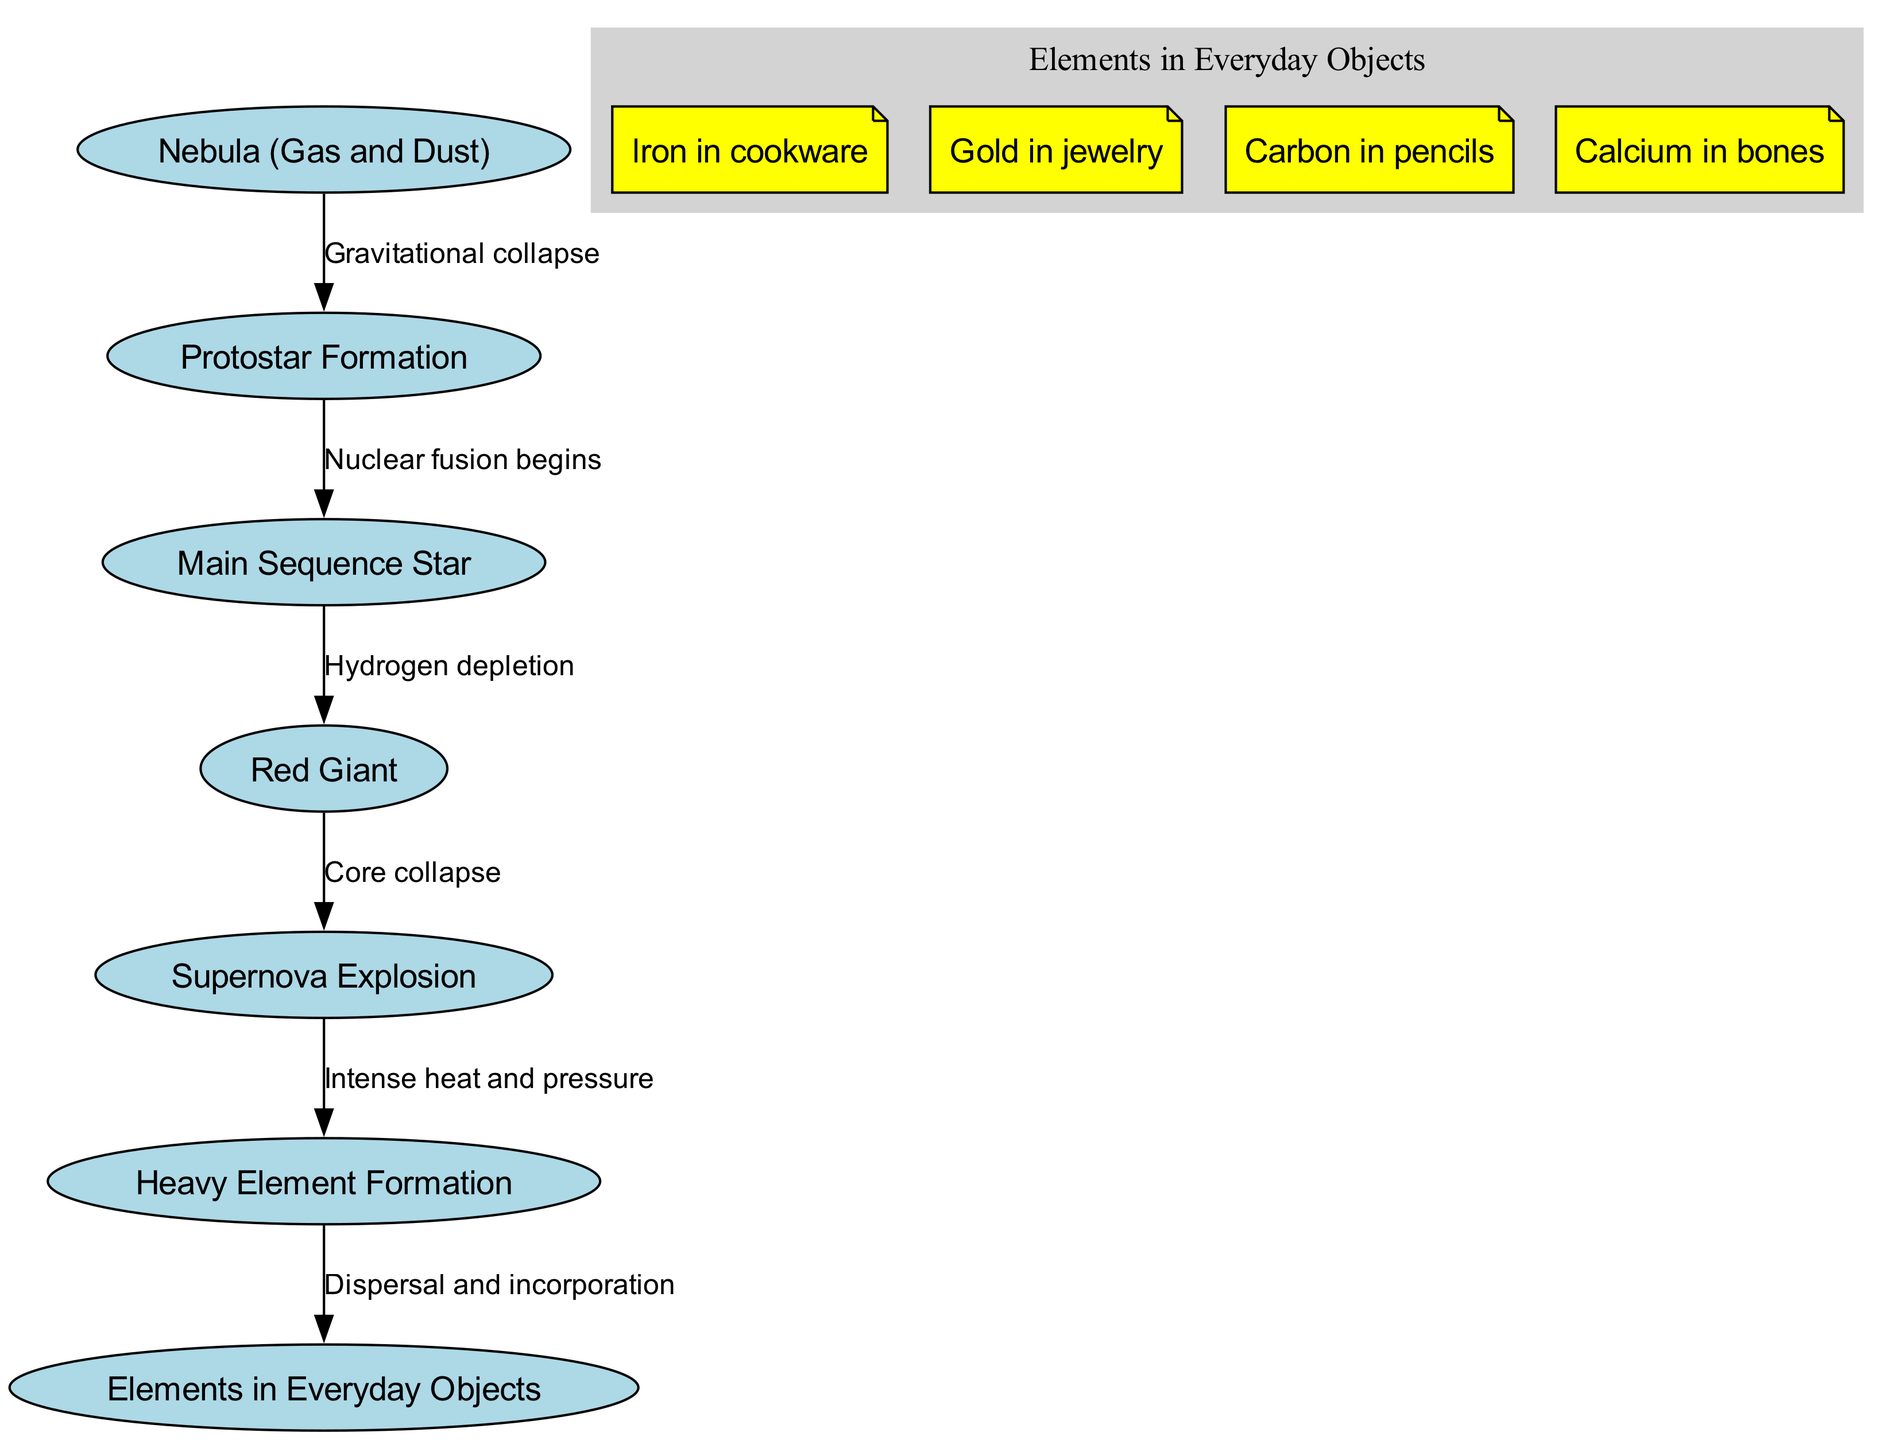What is the starting point in the life cycle of a star? The diagram shows that the life cycle of a star begins with the "Nebula (Gas and Dust)" node, which illustrates the initial stage where gas and dust are present.
Answer: Nebula (Gas and Dust) How many main phases are depicted in the star life cycle? Counting the nodes except for elements in everyday objects, there are five main phases: Nebula, Protostar, Main Sequence Star, Red Giant, and Supernova Explosion.
Answer: Five What process occurs between the protostar and the main sequence star? The diagram indicates that "Nuclear fusion begins" is the transition process from the protostar to the main sequence star.
Answer: Nuclear fusion begins What is formed after a supernova explosion? The diagram connects "Supernova Explosion" to "Heavy Element Formation," indicating that heavy elements are formed as a result of the supernova explosion.
Answer: Heavy Element Formation Which element is commonly found in cookware as a result of the life cycle of stars? The notes section of the diagram mentions "Iron in cookware," indicating that iron is a common element derived from the processes in the life cycle of stars.
Answer: Iron How does the life cycle of stars relate to common elements in everyday objects? The edges leading to "Elements in Everyday Objects" show that elements formed during the star processes are dispersed and incorporated into everyday items, such as iron, gold, carbon, and calcium.
Answer: Dispersal and incorporation What connection exists between hydrogen depletion and stellar evolution? The diagram illustrates that "Hydrogen depletion" leads to the transformation into a "Red Giant." Hydrogen is essential for nuclear fusion, and its depletion is a critical factor in the star's evolution.
Answer: Red Giant What event concludes the life cycle of a massive star according to the diagram? The "Core collapse" event is shown to occur after the Red Giant stage, leading to the eventual supernova explosion, which is the last phase for a massive star.
Answer: Supernova Explosion 